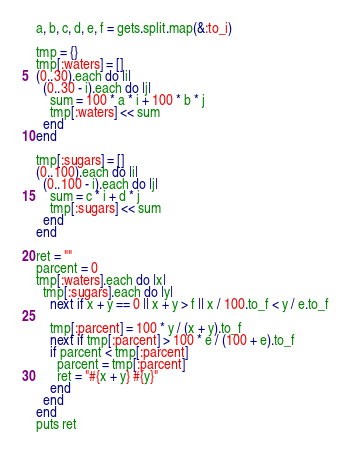Convert code to text. <code><loc_0><loc_0><loc_500><loc_500><_Ruby_>a, b, c, d, e, f = gets.split.map(&:to_i)

tmp = {}
tmp[:waters] = []
(0..30).each do |i|
  (0..30 - i).each do |j|
    sum = 100 * a * i + 100 * b * j
    tmp[:waters] << sum
  end
end

tmp[:sugars] = []
(0..100).each do |i|
  (0..100 - i).each do |j|
    sum = c * i + d * j
    tmp[:sugars] << sum
  end
end

ret = ""
parcent = 0
tmp[:waters].each do |x|
  tmp[:sugars].each do |y|
    next if x + y == 0 || x + y > f || x / 100.to_f < y / e.to_f

    tmp[:parcent] = 100 * y / (x + y).to_f
    next if tmp[:parcent] > 100 * e / (100 + e).to_f
    if parcent < tmp[:parcent]
      parcent = tmp[:parcent]
      ret = "#{x + y} #{y}"
    end
  end
end
puts ret
</code> 